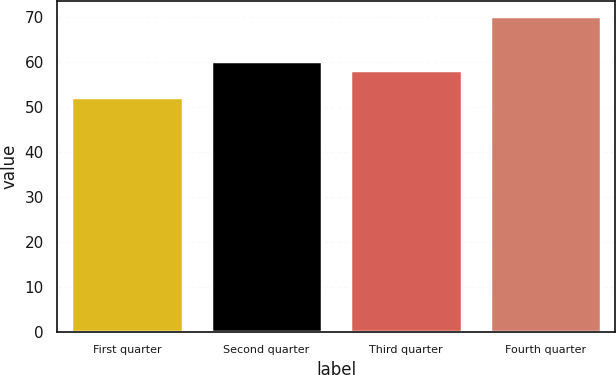Convert chart. <chart><loc_0><loc_0><loc_500><loc_500><bar_chart><fcel>First quarter<fcel>Second quarter<fcel>Third quarter<fcel>Fourth quarter<nl><fcel>52.25<fcel>60.19<fcel>58.39<fcel>70.2<nl></chart> 